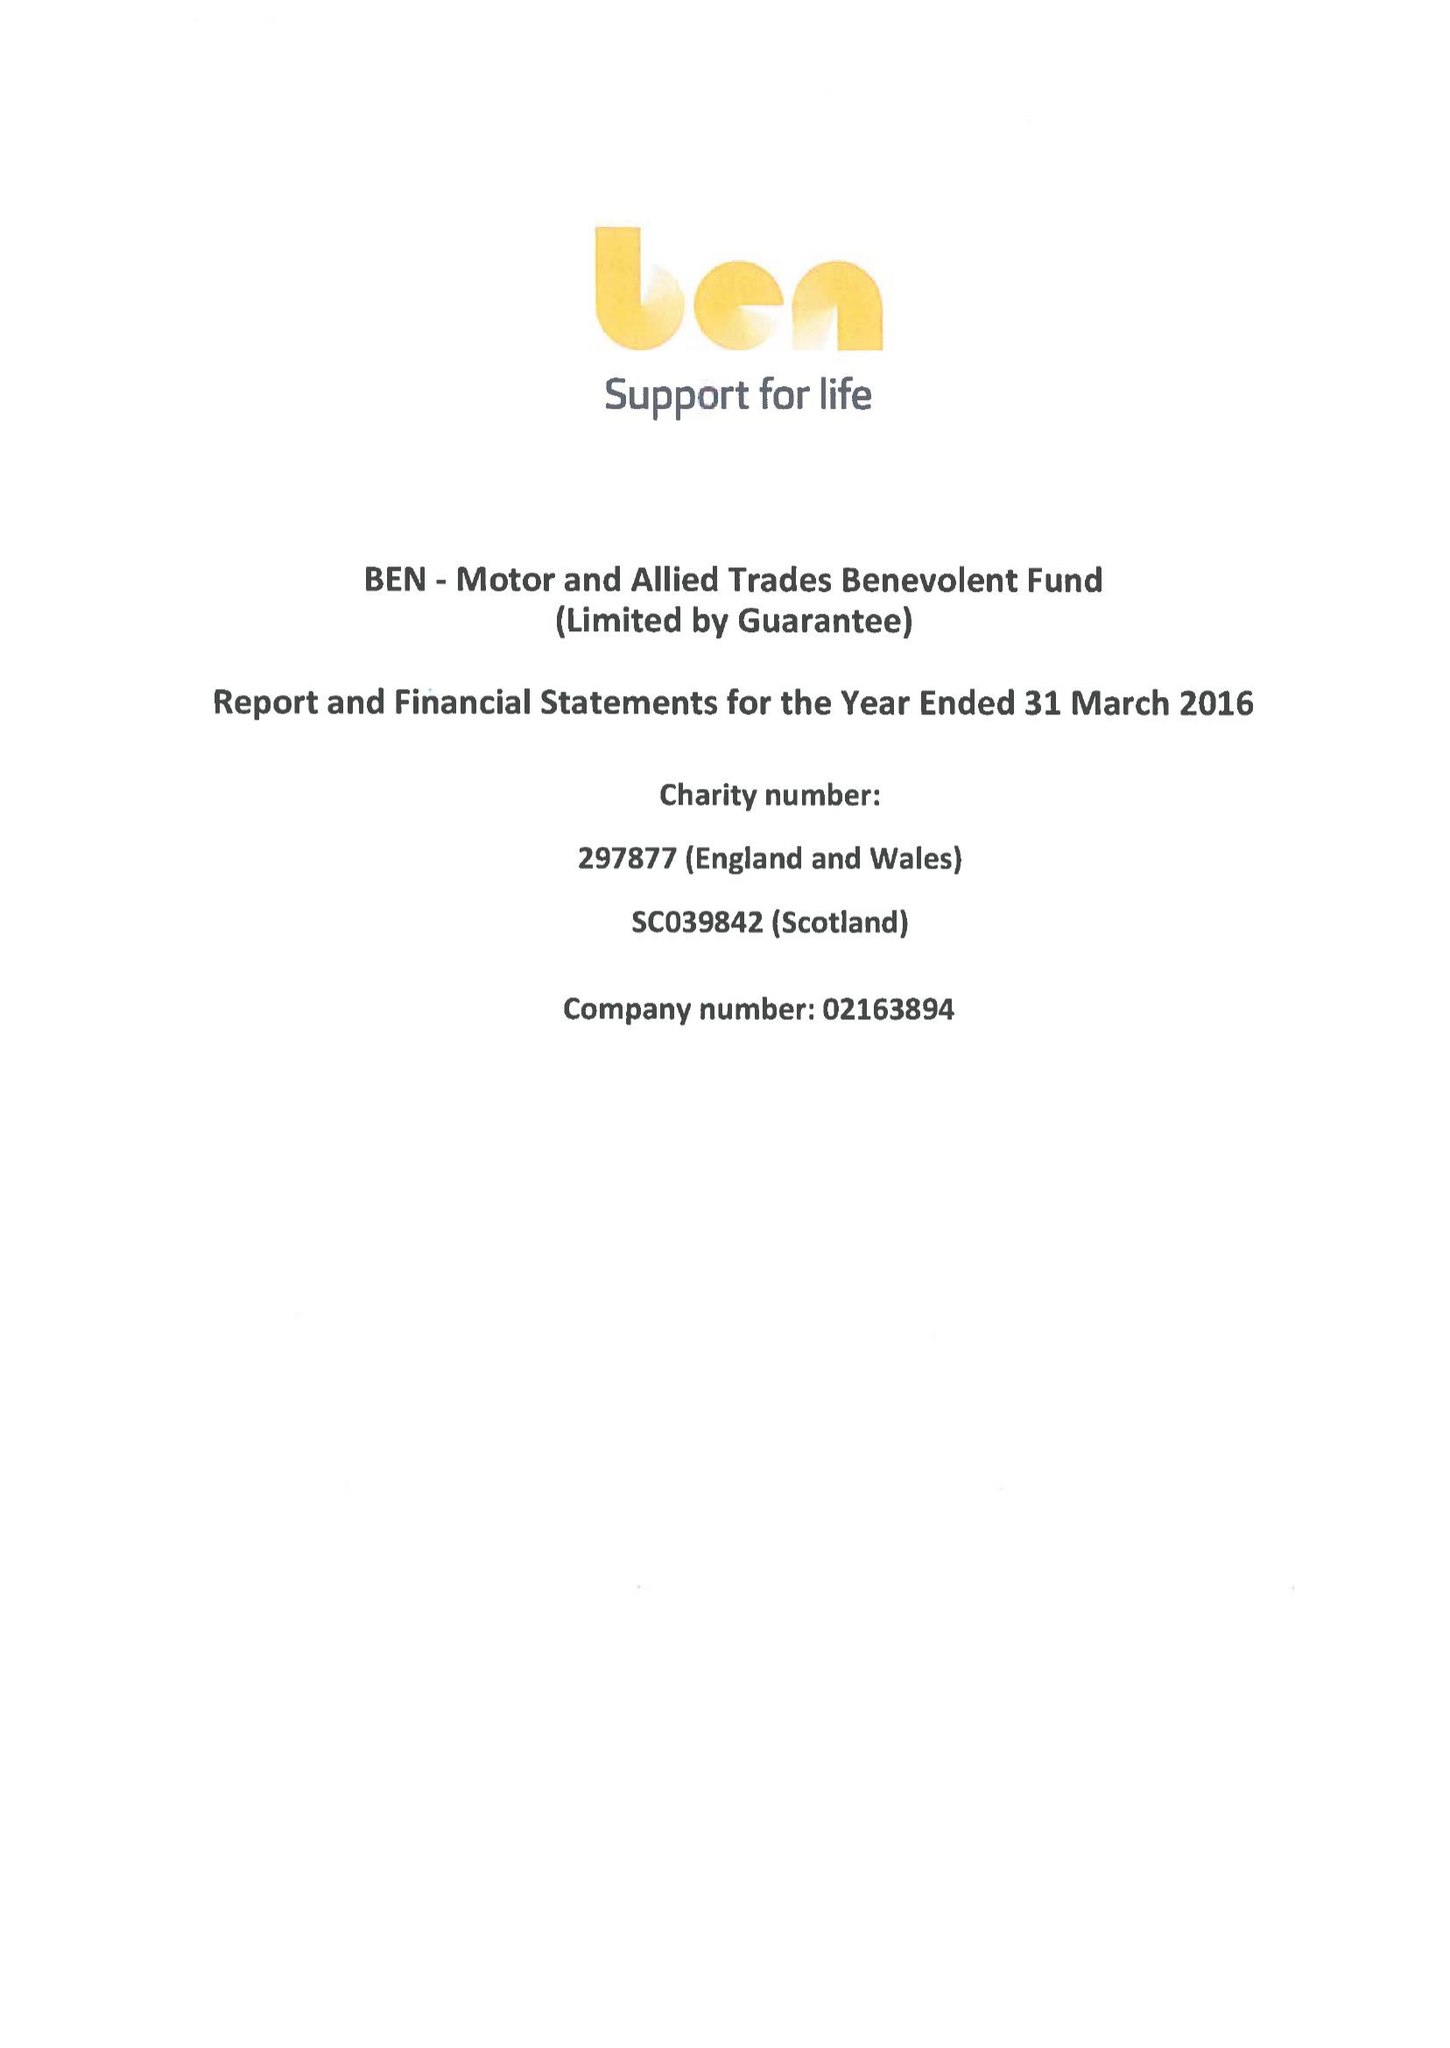What is the value for the spending_annually_in_british_pounds?
Answer the question using a single word or phrase. 27122000.00 